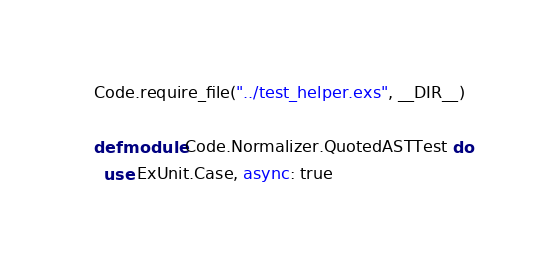<code> <loc_0><loc_0><loc_500><loc_500><_Elixir_>Code.require_file("../test_helper.exs", __DIR__)

defmodule Code.Normalizer.QuotedASTTest do
  use ExUnit.Case, async: true
</code> 